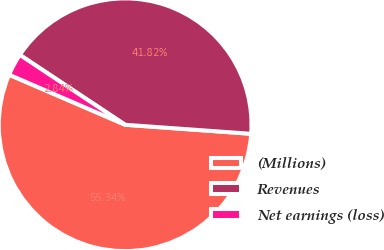Convert chart. <chart><loc_0><loc_0><loc_500><loc_500><pie_chart><fcel>(Millions)<fcel>Revenues<fcel>Net earnings (loss)<nl><fcel>55.34%<fcel>41.82%<fcel>2.84%<nl></chart> 